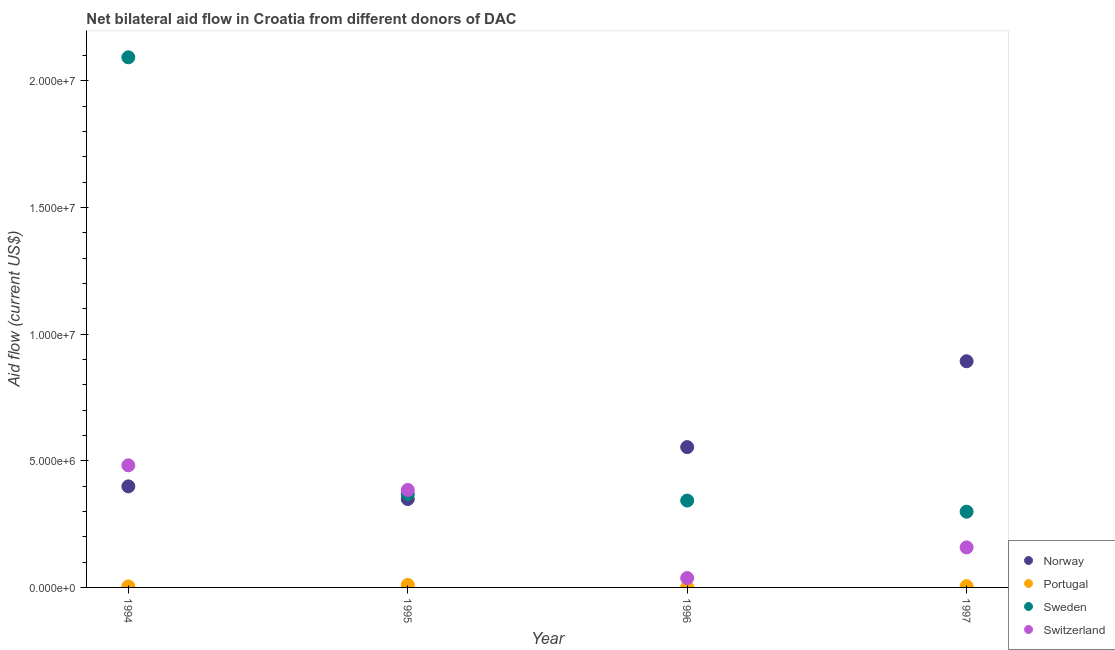What is the amount of aid given by sweden in 1996?
Offer a very short reply. 3.43e+06. Across all years, what is the maximum amount of aid given by sweden?
Provide a short and direct response. 2.09e+07. Across all years, what is the minimum amount of aid given by norway?
Give a very brief answer. 3.49e+06. In which year was the amount of aid given by sweden maximum?
Keep it short and to the point. 1994. In which year was the amount of aid given by portugal minimum?
Offer a terse response. 1996. What is the total amount of aid given by portugal in the graph?
Offer a terse response. 2.00e+05. What is the difference between the amount of aid given by norway in 1995 and that in 1996?
Make the answer very short. -2.05e+06. What is the difference between the amount of aid given by switzerland in 1996 and the amount of aid given by portugal in 1995?
Offer a terse response. 2.70e+05. What is the average amount of aid given by switzerland per year?
Keep it short and to the point. 2.66e+06. In the year 1996, what is the difference between the amount of aid given by portugal and amount of aid given by sweden?
Offer a terse response. -3.42e+06. What is the ratio of the amount of aid given by norway in 1994 to that in 1996?
Your response must be concise. 0.72. Is the amount of aid given by portugal in 1996 less than that in 1997?
Your answer should be compact. Yes. Is the difference between the amount of aid given by switzerland in 1994 and 1995 greater than the difference between the amount of aid given by sweden in 1994 and 1995?
Ensure brevity in your answer.  No. What is the difference between the highest and the second highest amount of aid given by sweden?
Offer a terse response. 1.72e+07. What is the difference between the highest and the lowest amount of aid given by sweden?
Offer a terse response. 1.79e+07. Is the sum of the amount of aid given by norway in 1995 and 1997 greater than the maximum amount of aid given by switzerland across all years?
Offer a very short reply. Yes. Is it the case that in every year, the sum of the amount of aid given by norway and amount of aid given by portugal is greater than the amount of aid given by sweden?
Offer a terse response. No. Does the amount of aid given by norway monotonically increase over the years?
Offer a terse response. No. Is the amount of aid given by norway strictly greater than the amount of aid given by portugal over the years?
Offer a very short reply. Yes. Is the amount of aid given by portugal strictly less than the amount of aid given by sweden over the years?
Your response must be concise. Yes. Does the graph contain grids?
Offer a terse response. No. What is the title of the graph?
Your answer should be very brief. Net bilateral aid flow in Croatia from different donors of DAC. Does "Taxes on income" appear as one of the legend labels in the graph?
Your response must be concise. No. What is the label or title of the X-axis?
Give a very brief answer. Year. What is the label or title of the Y-axis?
Keep it short and to the point. Aid flow (current US$). What is the Aid flow (current US$) of Norway in 1994?
Offer a very short reply. 3.99e+06. What is the Aid flow (current US$) in Portugal in 1994?
Your answer should be very brief. 4.00e+04. What is the Aid flow (current US$) in Sweden in 1994?
Your answer should be compact. 2.09e+07. What is the Aid flow (current US$) of Switzerland in 1994?
Provide a succinct answer. 4.82e+06. What is the Aid flow (current US$) in Norway in 1995?
Offer a terse response. 3.49e+06. What is the Aid flow (current US$) in Sweden in 1995?
Give a very brief answer. 3.69e+06. What is the Aid flow (current US$) of Switzerland in 1995?
Provide a succinct answer. 3.85e+06. What is the Aid flow (current US$) in Norway in 1996?
Provide a short and direct response. 5.54e+06. What is the Aid flow (current US$) in Sweden in 1996?
Your response must be concise. 3.43e+06. What is the Aid flow (current US$) in Norway in 1997?
Provide a succinct answer. 8.93e+06. What is the Aid flow (current US$) in Portugal in 1997?
Make the answer very short. 5.00e+04. What is the Aid flow (current US$) of Sweden in 1997?
Provide a succinct answer. 2.99e+06. What is the Aid flow (current US$) in Switzerland in 1997?
Your response must be concise. 1.58e+06. Across all years, what is the maximum Aid flow (current US$) in Norway?
Your answer should be very brief. 8.93e+06. Across all years, what is the maximum Aid flow (current US$) in Sweden?
Give a very brief answer. 2.09e+07. Across all years, what is the maximum Aid flow (current US$) of Switzerland?
Your answer should be compact. 4.82e+06. Across all years, what is the minimum Aid flow (current US$) in Norway?
Keep it short and to the point. 3.49e+06. Across all years, what is the minimum Aid flow (current US$) in Sweden?
Provide a succinct answer. 2.99e+06. Across all years, what is the minimum Aid flow (current US$) in Switzerland?
Your answer should be compact. 3.70e+05. What is the total Aid flow (current US$) of Norway in the graph?
Your response must be concise. 2.20e+07. What is the total Aid flow (current US$) of Sweden in the graph?
Give a very brief answer. 3.10e+07. What is the total Aid flow (current US$) of Switzerland in the graph?
Offer a very short reply. 1.06e+07. What is the difference between the Aid flow (current US$) of Sweden in 1994 and that in 1995?
Ensure brevity in your answer.  1.72e+07. What is the difference between the Aid flow (current US$) in Switzerland in 1994 and that in 1995?
Provide a short and direct response. 9.70e+05. What is the difference between the Aid flow (current US$) in Norway in 1994 and that in 1996?
Your response must be concise. -1.55e+06. What is the difference between the Aid flow (current US$) in Portugal in 1994 and that in 1996?
Your answer should be compact. 3.00e+04. What is the difference between the Aid flow (current US$) in Sweden in 1994 and that in 1996?
Give a very brief answer. 1.75e+07. What is the difference between the Aid flow (current US$) in Switzerland in 1994 and that in 1996?
Offer a terse response. 4.45e+06. What is the difference between the Aid flow (current US$) of Norway in 1994 and that in 1997?
Make the answer very short. -4.94e+06. What is the difference between the Aid flow (current US$) in Sweden in 1994 and that in 1997?
Provide a succinct answer. 1.79e+07. What is the difference between the Aid flow (current US$) of Switzerland in 1994 and that in 1997?
Provide a short and direct response. 3.24e+06. What is the difference between the Aid flow (current US$) in Norway in 1995 and that in 1996?
Keep it short and to the point. -2.05e+06. What is the difference between the Aid flow (current US$) in Portugal in 1995 and that in 1996?
Keep it short and to the point. 9.00e+04. What is the difference between the Aid flow (current US$) of Switzerland in 1995 and that in 1996?
Ensure brevity in your answer.  3.48e+06. What is the difference between the Aid flow (current US$) in Norway in 1995 and that in 1997?
Provide a short and direct response. -5.44e+06. What is the difference between the Aid flow (current US$) of Switzerland in 1995 and that in 1997?
Provide a succinct answer. 2.27e+06. What is the difference between the Aid flow (current US$) in Norway in 1996 and that in 1997?
Offer a very short reply. -3.39e+06. What is the difference between the Aid flow (current US$) in Sweden in 1996 and that in 1997?
Offer a terse response. 4.40e+05. What is the difference between the Aid flow (current US$) in Switzerland in 1996 and that in 1997?
Your answer should be very brief. -1.21e+06. What is the difference between the Aid flow (current US$) of Norway in 1994 and the Aid flow (current US$) of Portugal in 1995?
Make the answer very short. 3.89e+06. What is the difference between the Aid flow (current US$) of Norway in 1994 and the Aid flow (current US$) of Sweden in 1995?
Offer a very short reply. 3.00e+05. What is the difference between the Aid flow (current US$) of Norway in 1994 and the Aid flow (current US$) of Switzerland in 1995?
Provide a short and direct response. 1.40e+05. What is the difference between the Aid flow (current US$) in Portugal in 1994 and the Aid flow (current US$) in Sweden in 1995?
Offer a very short reply. -3.65e+06. What is the difference between the Aid flow (current US$) in Portugal in 1994 and the Aid flow (current US$) in Switzerland in 1995?
Keep it short and to the point. -3.81e+06. What is the difference between the Aid flow (current US$) in Sweden in 1994 and the Aid flow (current US$) in Switzerland in 1995?
Your answer should be compact. 1.71e+07. What is the difference between the Aid flow (current US$) in Norway in 1994 and the Aid flow (current US$) in Portugal in 1996?
Provide a succinct answer. 3.98e+06. What is the difference between the Aid flow (current US$) in Norway in 1994 and the Aid flow (current US$) in Sweden in 1996?
Your answer should be very brief. 5.60e+05. What is the difference between the Aid flow (current US$) of Norway in 1994 and the Aid flow (current US$) of Switzerland in 1996?
Keep it short and to the point. 3.62e+06. What is the difference between the Aid flow (current US$) in Portugal in 1994 and the Aid flow (current US$) in Sweden in 1996?
Keep it short and to the point. -3.39e+06. What is the difference between the Aid flow (current US$) of Portugal in 1994 and the Aid flow (current US$) of Switzerland in 1996?
Your response must be concise. -3.30e+05. What is the difference between the Aid flow (current US$) of Sweden in 1994 and the Aid flow (current US$) of Switzerland in 1996?
Provide a short and direct response. 2.06e+07. What is the difference between the Aid flow (current US$) of Norway in 1994 and the Aid flow (current US$) of Portugal in 1997?
Offer a terse response. 3.94e+06. What is the difference between the Aid flow (current US$) of Norway in 1994 and the Aid flow (current US$) of Sweden in 1997?
Keep it short and to the point. 1.00e+06. What is the difference between the Aid flow (current US$) of Norway in 1994 and the Aid flow (current US$) of Switzerland in 1997?
Offer a very short reply. 2.41e+06. What is the difference between the Aid flow (current US$) of Portugal in 1994 and the Aid flow (current US$) of Sweden in 1997?
Keep it short and to the point. -2.95e+06. What is the difference between the Aid flow (current US$) in Portugal in 1994 and the Aid flow (current US$) in Switzerland in 1997?
Give a very brief answer. -1.54e+06. What is the difference between the Aid flow (current US$) in Sweden in 1994 and the Aid flow (current US$) in Switzerland in 1997?
Keep it short and to the point. 1.94e+07. What is the difference between the Aid flow (current US$) of Norway in 1995 and the Aid flow (current US$) of Portugal in 1996?
Your response must be concise. 3.48e+06. What is the difference between the Aid flow (current US$) in Norway in 1995 and the Aid flow (current US$) in Switzerland in 1996?
Provide a short and direct response. 3.12e+06. What is the difference between the Aid flow (current US$) in Portugal in 1995 and the Aid flow (current US$) in Sweden in 1996?
Ensure brevity in your answer.  -3.33e+06. What is the difference between the Aid flow (current US$) of Portugal in 1995 and the Aid flow (current US$) of Switzerland in 1996?
Offer a terse response. -2.70e+05. What is the difference between the Aid flow (current US$) in Sweden in 1995 and the Aid flow (current US$) in Switzerland in 1996?
Offer a very short reply. 3.32e+06. What is the difference between the Aid flow (current US$) of Norway in 1995 and the Aid flow (current US$) of Portugal in 1997?
Give a very brief answer. 3.44e+06. What is the difference between the Aid flow (current US$) in Norway in 1995 and the Aid flow (current US$) in Sweden in 1997?
Offer a very short reply. 5.00e+05. What is the difference between the Aid flow (current US$) of Norway in 1995 and the Aid flow (current US$) of Switzerland in 1997?
Your answer should be compact. 1.91e+06. What is the difference between the Aid flow (current US$) of Portugal in 1995 and the Aid flow (current US$) of Sweden in 1997?
Your response must be concise. -2.89e+06. What is the difference between the Aid flow (current US$) in Portugal in 1995 and the Aid flow (current US$) in Switzerland in 1997?
Your answer should be compact. -1.48e+06. What is the difference between the Aid flow (current US$) in Sweden in 1995 and the Aid flow (current US$) in Switzerland in 1997?
Offer a terse response. 2.11e+06. What is the difference between the Aid flow (current US$) of Norway in 1996 and the Aid flow (current US$) of Portugal in 1997?
Offer a very short reply. 5.49e+06. What is the difference between the Aid flow (current US$) in Norway in 1996 and the Aid flow (current US$) in Sweden in 1997?
Your answer should be very brief. 2.55e+06. What is the difference between the Aid flow (current US$) of Norway in 1996 and the Aid flow (current US$) of Switzerland in 1997?
Offer a terse response. 3.96e+06. What is the difference between the Aid flow (current US$) in Portugal in 1996 and the Aid flow (current US$) in Sweden in 1997?
Your answer should be very brief. -2.98e+06. What is the difference between the Aid flow (current US$) in Portugal in 1996 and the Aid flow (current US$) in Switzerland in 1997?
Provide a succinct answer. -1.57e+06. What is the difference between the Aid flow (current US$) of Sweden in 1996 and the Aid flow (current US$) of Switzerland in 1997?
Provide a succinct answer. 1.85e+06. What is the average Aid flow (current US$) in Norway per year?
Offer a very short reply. 5.49e+06. What is the average Aid flow (current US$) in Sweden per year?
Your response must be concise. 7.76e+06. What is the average Aid flow (current US$) in Switzerland per year?
Your response must be concise. 2.66e+06. In the year 1994, what is the difference between the Aid flow (current US$) in Norway and Aid flow (current US$) in Portugal?
Provide a succinct answer. 3.95e+06. In the year 1994, what is the difference between the Aid flow (current US$) of Norway and Aid flow (current US$) of Sweden?
Provide a short and direct response. -1.69e+07. In the year 1994, what is the difference between the Aid flow (current US$) in Norway and Aid flow (current US$) in Switzerland?
Keep it short and to the point. -8.30e+05. In the year 1994, what is the difference between the Aid flow (current US$) of Portugal and Aid flow (current US$) of Sweden?
Make the answer very short. -2.09e+07. In the year 1994, what is the difference between the Aid flow (current US$) in Portugal and Aid flow (current US$) in Switzerland?
Give a very brief answer. -4.78e+06. In the year 1994, what is the difference between the Aid flow (current US$) of Sweden and Aid flow (current US$) of Switzerland?
Provide a short and direct response. 1.61e+07. In the year 1995, what is the difference between the Aid flow (current US$) in Norway and Aid flow (current US$) in Portugal?
Your answer should be very brief. 3.39e+06. In the year 1995, what is the difference between the Aid flow (current US$) of Norway and Aid flow (current US$) of Sweden?
Ensure brevity in your answer.  -2.00e+05. In the year 1995, what is the difference between the Aid flow (current US$) in Norway and Aid flow (current US$) in Switzerland?
Provide a short and direct response. -3.60e+05. In the year 1995, what is the difference between the Aid flow (current US$) in Portugal and Aid flow (current US$) in Sweden?
Offer a terse response. -3.59e+06. In the year 1995, what is the difference between the Aid flow (current US$) of Portugal and Aid flow (current US$) of Switzerland?
Offer a very short reply. -3.75e+06. In the year 1995, what is the difference between the Aid flow (current US$) in Sweden and Aid flow (current US$) in Switzerland?
Make the answer very short. -1.60e+05. In the year 1996, what is the difference between the Aid flow (current US$) in Norway and Aid flow (current US$) in Portugal?
Keep it short and to the point. 5.53e+06. In the year 1996, what is the difference between the Aid flow (current US$) in Norway and Aid flow (current US$) in Sweden?
Provide a succinct answer. 2.11e+06. In the year 1996, what is the difference between the Aid flow (current US$) of Norway and Aid flow (current US$) of Switzerland?
Offer a very short reply. 5.17e+06. In the year 1996, what is the difference between the Aid flow (current US$) in Portugal and Aid flow (current US$) in Sweden?
Ensure brevity in your answer.  -3.42e+06. In the year 1996, what is the difference between the Aid flow (current US$) of Portugal and Aid flow (current US$) of Switzerland?
Give a very brief answer. -3.60e+05. In the year 1996, what is the difference between the Aid flow (current US$) of Sweden and Aid flow (current US$) of Switzerland?
Your response must be concise. 3.06e+06. In the year 1997, what is the difference between the Aid flow (current US$) of Norway and Aid flow (current US$) of Portugal?
Keep it short and to the point. 8.88e+06. In the year 1997, what is the difference between the Aid flow (current US$) in Norway and Aid flow (current US$) in Sweden?
Your answer should be very brief. 5.94e+06. In the year 1997, what is the difference between the Aid flow (current US$) in Norway and Aid flow (current US$) in Switzerland?
Your answer should be compact. 7.35e+06. In the year 1997, what is the difference between the Aid flow (current US$) of Portugal and Aid flow (current US$) of Sweden?
Make the answer very short. -2.94e+06. In the year 1997, what is the difference between the Aid flow (current US$) in Portugal and Aid flow (current US$) in Switzerland?
Your response must be concise. -1.53e+06. In the year 1997, what is the difference between the Aid flow (current US$) in Sweden and Aid flow (current US$) in Switzerland?
Offer a terse response. 1.41e+06. What is the ratio of the Aid flow (current US$) in Norway in 1994 to that in 1995?
Offer a terse response. 1.14. What is the ratio of the Aid flow (current US$) of Sweden in 1994 to that in 1995?
Offer a very short reply. 5.67. What is the ratio of the Aid flow (current US$) of Switzerland in 1994 to that in 1995?
Keep it short and to the point. 1.25. What is the ratio of the Aid flow (current US$) in Norway in 1994 to that in 1996?
Ensure brevity in your answer.  0.72. What is the ratio of the Aid flow (current US$) in Sweden in 1994 to that in 1996?
Give a very brief answer. 6.1. What is the ratio of the Aid flow (current US$) of Switzerland in 1994 to that in 1996?
Provide a succinct answer. 13.03. What is the ratio of the Aid flow (current US$) in Norway in 1994 to that in 1997?
Your answer should be compact. 0.45. What is the ratio of the Aid flow (current US$) of Switzerland in 1994 to that in 1997?
Offer a terse response. 3.05. What is the ratio of the Aid flow (current US$) of Norway in 1995 to that in 1996?
Your answer should be very brief. 0.63. What is the ratio of the Aid flow (current US$) of Portugal in 1995 to that in 1996?
Your response must be concise. 10. What is the ratio of the Aid flow (current US$) in Sweden in 1995 to that in 1996?
Keep it short and to the point. 1.08. What is the ratio of the Aid flow (current US$) in Switzerland in 1995 to that in 1996?
Ensure brevity in your answer.  10.41. What is the ratio of the Aid flow (current US$) in Norway in 1995 to that in 1997?
Offer a very short reply. 0.39. What is the ratio of the Aid flow (current US$) in Portugal in 1995 to that in 1997?
Provide a succinct answer. 2. What is the ratio of the Aid flow (current US$) in Sweden in 1995 to that in 1997?
Provide a succinct answer. 1.23. What is the ratio of the Aid flow (current US$) of Switzerland in 1995 to that in 1997?
Your response must be concise. 2.44. What is the ratio of the Aid flow (current US$) of Norway in 1996 to that in 1997?
Provide a short and direct response. 0.62. What is the ratio of the Aid flow (current US$) in Sweden in 1996 to that in 1997?
Your response must be concise. 1.15. What is the ratio of the Aid flow (current US$) of Switzerland in 1996 to that in 1997?
Your answer should be very brief. 0.23. What is the difference between the highest and the second highest Aid flow (current US$) in Norway?
Your answer should be compact. 3.39e+06. What is the difference between the highest and the second highest Aid flow (current US$) in Sweden?
Your answer should be very brief. 1.72e+07. What is the difference between the highest and the second highest Aid flow (current US$) in Switzerland?
Provide a succinct answer. 9.70e+05. What is the difference between the highest and the lowest Aid flow (current US$) of Norway?
Keep it short and to the point. 5.44e+06. What is the difference between the highest and the lowest Aid flow (current US$) in Sweden?
Offer a very short reply. 1.79e+07. What is the difference between the highest and the lowest Aid flow (current US$) in Switzerland?
Provide a short and direct response. 4.45e+06. 